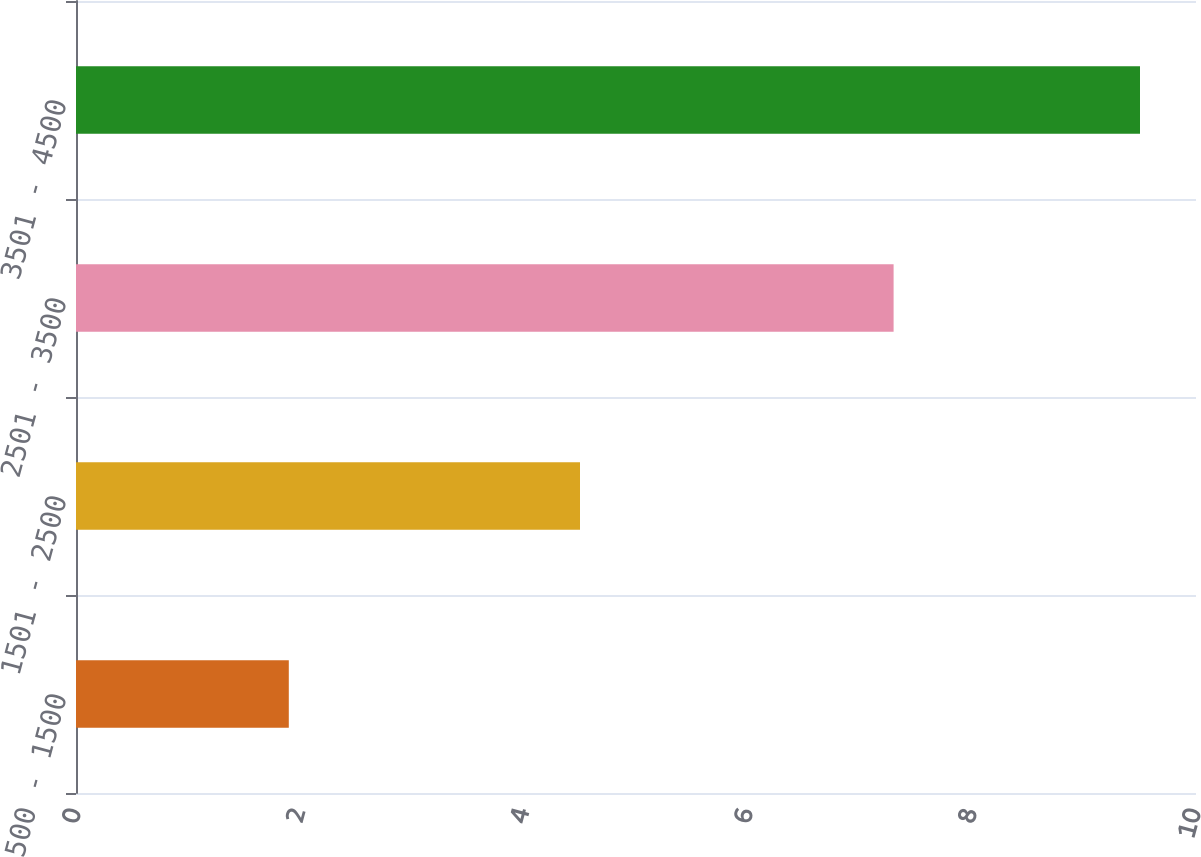<chart> <loc_0><loc_0><loc_500><loc_500><bar_chart><fcel>500 - 1500<fcel>1501 - 2500<fcel>2501 - 3500<fcel>3501 - 4500<nl><fcel>1.9<fcel>4.5<fcel>7.3<fcel>9.5<nl></chart> 